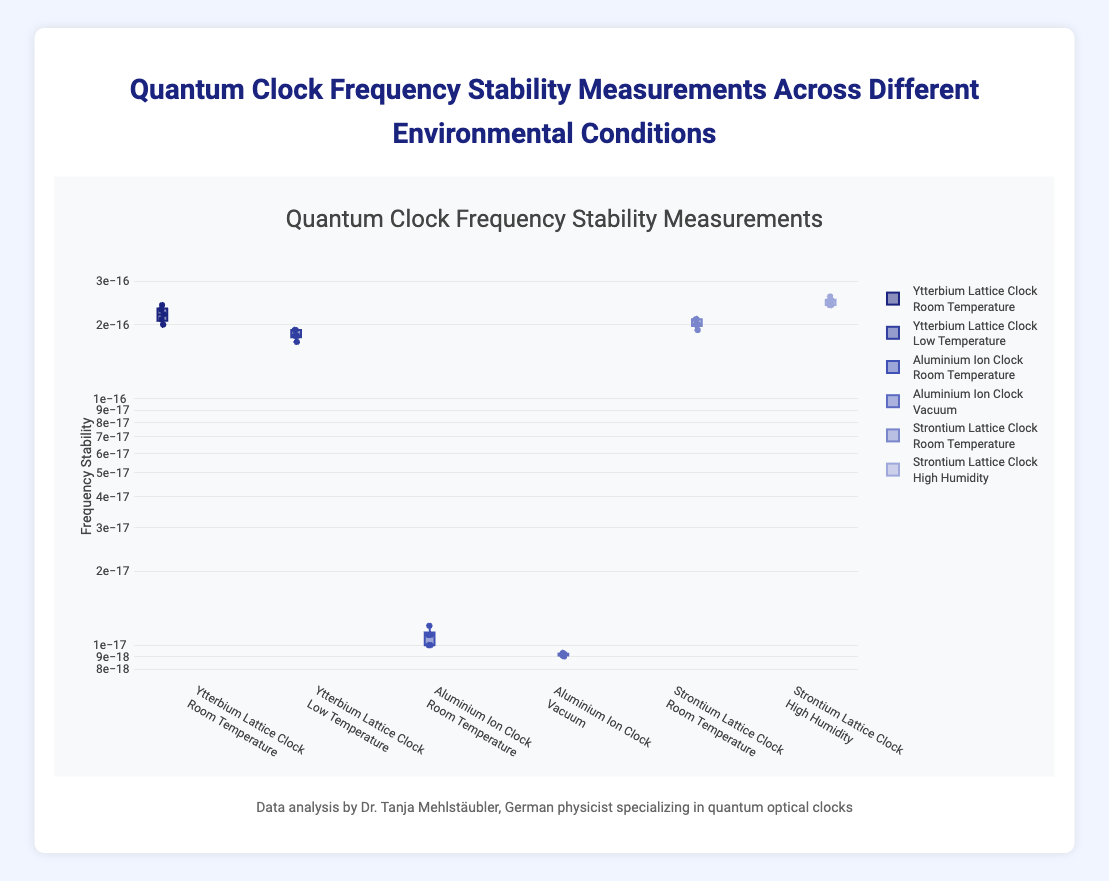Which clock has the highest median frequency stability measurement in room temperature conditions? To determine the highest median frequency stability measurement among clocks in room temperature, we need to look at the medians of "Ytterbium Lattice Clock," "Aluminium Ion Clock," and "Strontium Lattice Clock" in Room Temperature condition. From the box plot, the median values are comparative; "Ytterbium Lattice Clock" has around 2.2e-16, "Aluminium Ion Clock" has around 1.1e-17, and "Strontium Lattice Clock" has around 2.0e-16.
Answer: Ytterbium Lattice Clock What's the range of the frequency stability measurements for the Aluminium Ion Clock in a vacuum? The range in a box plot is the difference between the maximum and minimum values in the dataset. From the box plot for the Aluminium Ion Clock in a vacuum, the maximum is around 9.3e-18 and the minimum is around 9.0e-18. Therefore, the range is (9.3e-18 - 9.0e-18).
Answer: 3e-19 Which environmental condition results in the worst frequency stability for the Strontium Lattice Clock? To find the environmental condition that results in the worst frequency stability for the Strontium Lattice Clock, we compare the median values and the spread of the data points under different conditions. The conditions are Room Temperature and High Humidity. The High Humidity condition has a higher median at approximately 2.5e-16 and larger spread compared to Room Temperature.
Answer: High Humidity How does the spread of the frequency stability measurements differ between the Ytterbium Lattice Clock at room temperature and low temperature? The spread is indicated by the interquartile range (IQR) and the overall range from minimum to maximum values. For the Ytterbium Lattice Clock, the Room Temperature condition has higher variability compared to the Low Temperature condition, which means the stability measurements are more spread out at room temperature.
Answer: More spread out at Room Temperature What is the median frequency stability measurement for the Aluminium Ion Clock at room temperature? The median can be located as the middle line in the box plot. For the Aluminium Ion Clock at room temperature, the median stability measurement is at the center of the box, around 1.1e-17.
Answer: 1.1e-17 Which clock and environmental condition combination has the lowest variability in frequency stability measurements? The combination with the lowest variability can be identified by the smallest interquartile range (IQR). Comparing the IQRs of all combinations, the Aluminium Ion Clock in a vacuum shows the smallest spread.
Answer: Aluminium Ion Clock in Vacuum What is the interquartile range (IQR) of the Ytterbium Lattice Clock at room temperature? The IQR is the range between the first quartile (Q1) and third quartile (Q3). For the Ytterbium Lattice Clock at room temperature, Q1 is around 2.1e-16 and Q3 is around 2.3e-16, thus the IQR is (2.3e-16 - 2.1e-16).
Answer: 2.0e-17 